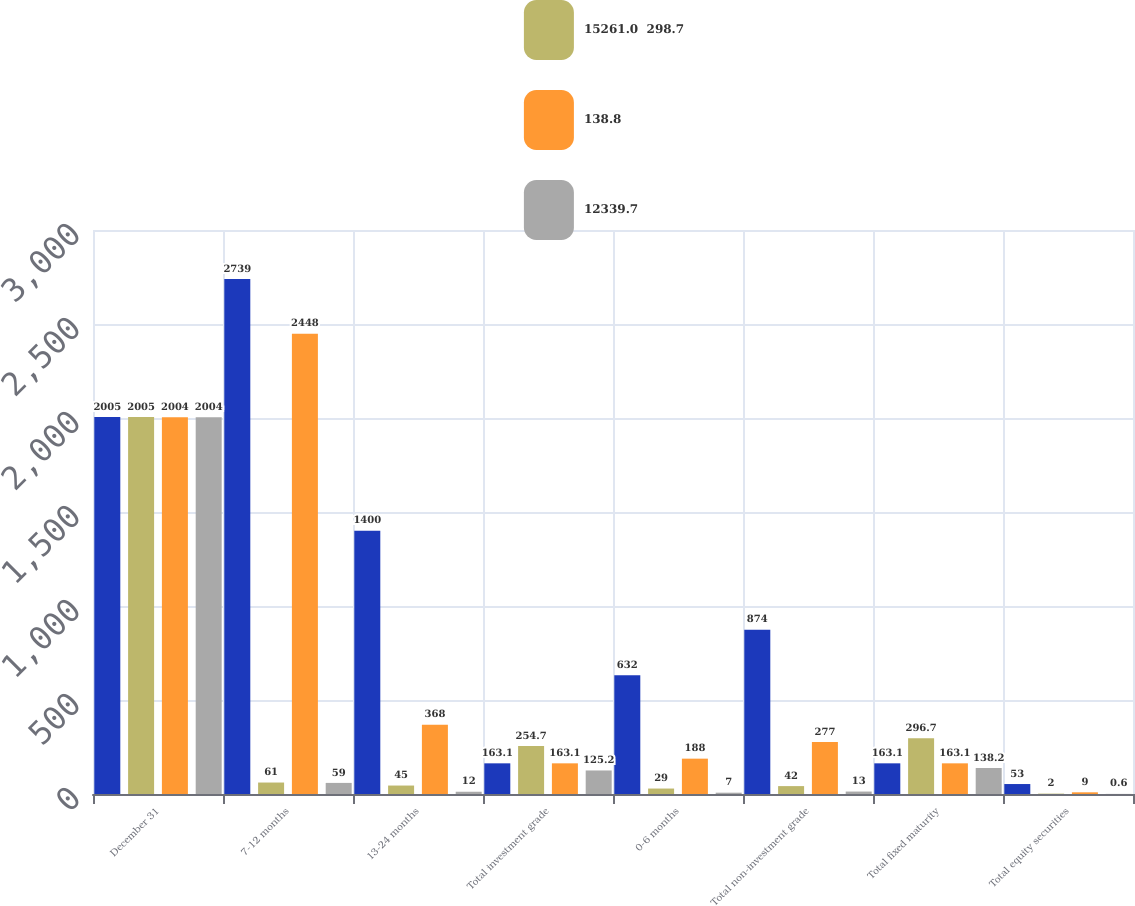Convert chart. <chart><loc_0><loc_0><loc_500><loc_500><stacked_bar_chart><ecel><fcel>December 31<fcel>7-12 months<fcel>13-24 months<fcel>Total investment grade<fcel>0-6 months<fcel>Total non-investment grade<fcel>Total fixed maturity<fcel>Total equity securities<nl><fcel>nan<fcel>2005<fcel>2739<fcel>1400<fcel>163.1<fcel>632<fcel>874<fcel>163.1<fcel>53<nl><fcel>15261.0  298.7<fcel>2005<fcel>61<fcel>45<fcel>254.7<fcel>29<fcel>42<fcel>296.7<fcel>2<nl><fcel>138.8<fcel>2004<fcel>2448<fcel>368<fcel>163.1<fcel>188<fcel>277<fcel>163.1<fcel>9<nl><fcel>12339.7<fcel>2004<fcel>59<fcel>12<fcel>125.2<fcel>7<fcel>13<fcel>138.2<fcel>0.6<nl></chart> 